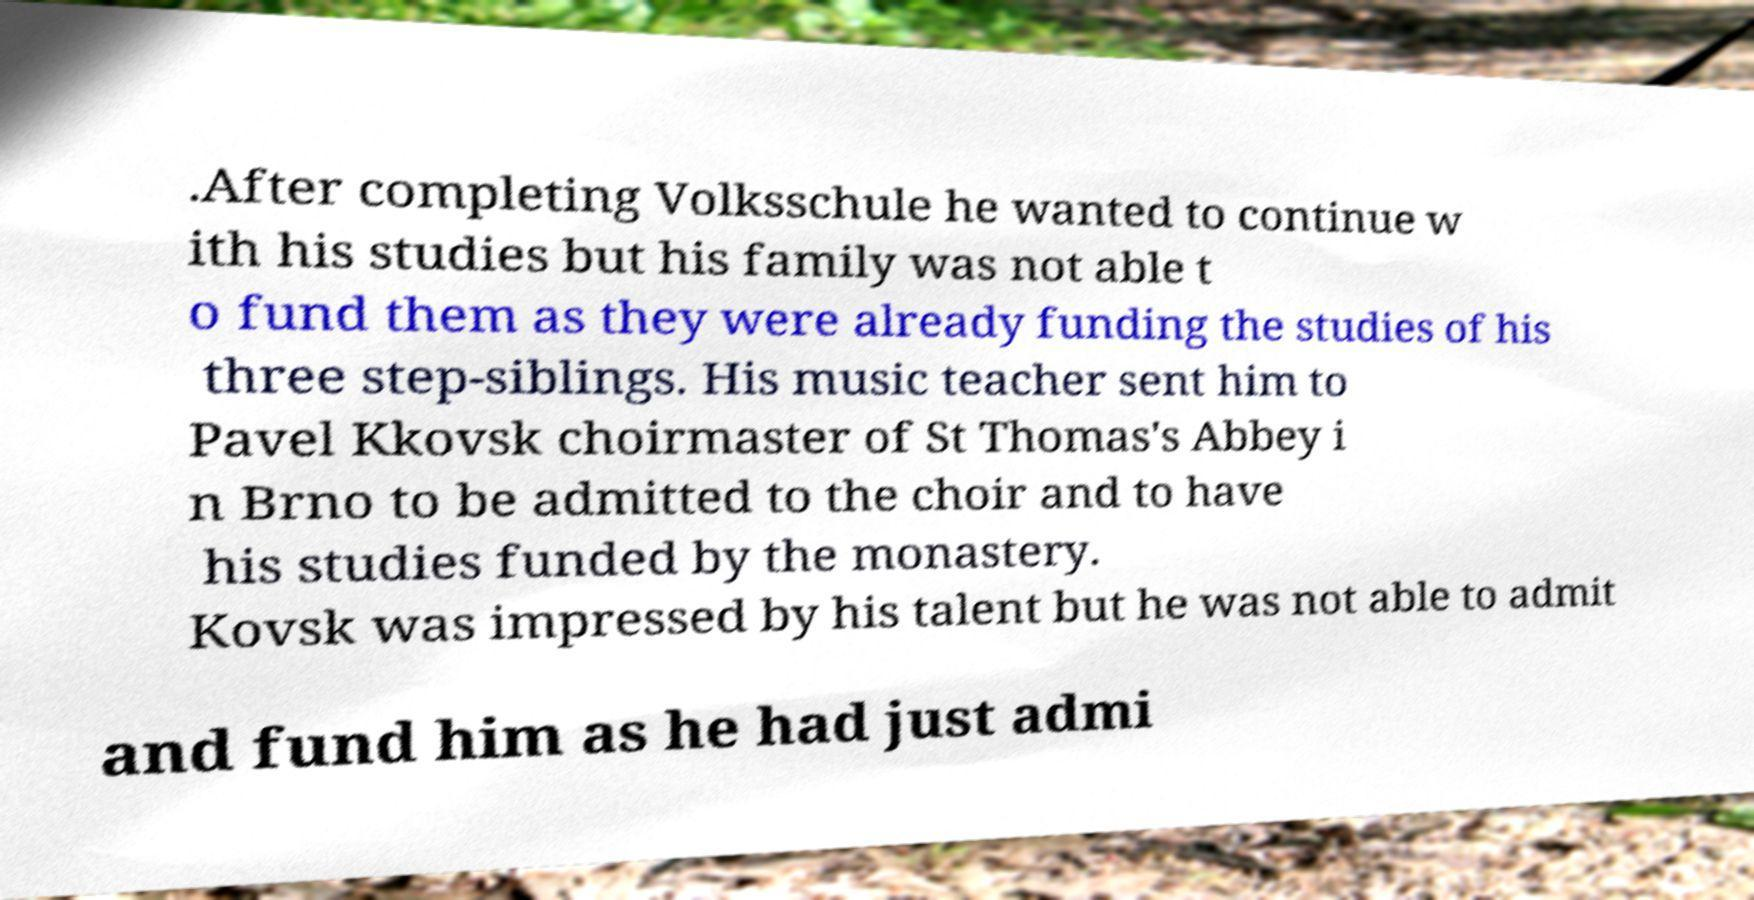I need the written content from this picture converted into text. Can you do that? .After completing Volksschule he wanted to continue w ith his studies but his family was not able t o fund them as they were already funding the studies of his three step-siblings. His music teacher sent him to Pavel Kkovsk choirmaster of St Thomas's Abbey i n Brno to be admitted to the choir and to have his studies funded by the monastery. Kovsk was impressed by his talent but he was not able to admit and fund him as he had just admi 